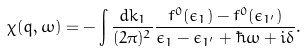Convert formula to latex. <formula><loc_0><loc_0><loc_500><loc_500>\chi ( { q } , \omega ) = - \int \frac { d { k } _ { 1 } } { ( 2 \pi ) ^ { 2 } } \frac { f ^ { 0 } ( \epsilon _ { 1 } ) - f ^ { 0 } ( \epsilon _ { 1 ^ { \prime } } ) } { \epsilon _ { 1 } - \epsilon _ { 1 ^ { \prime } } + \hbar { \omega } + i \delta } .</formula> 